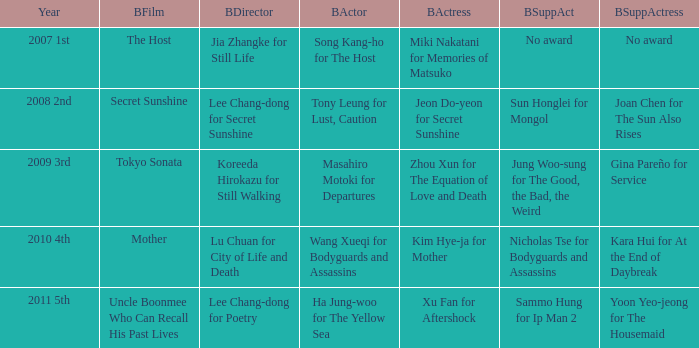Name the year for sammo hung for ip man 2 2011 5th. 